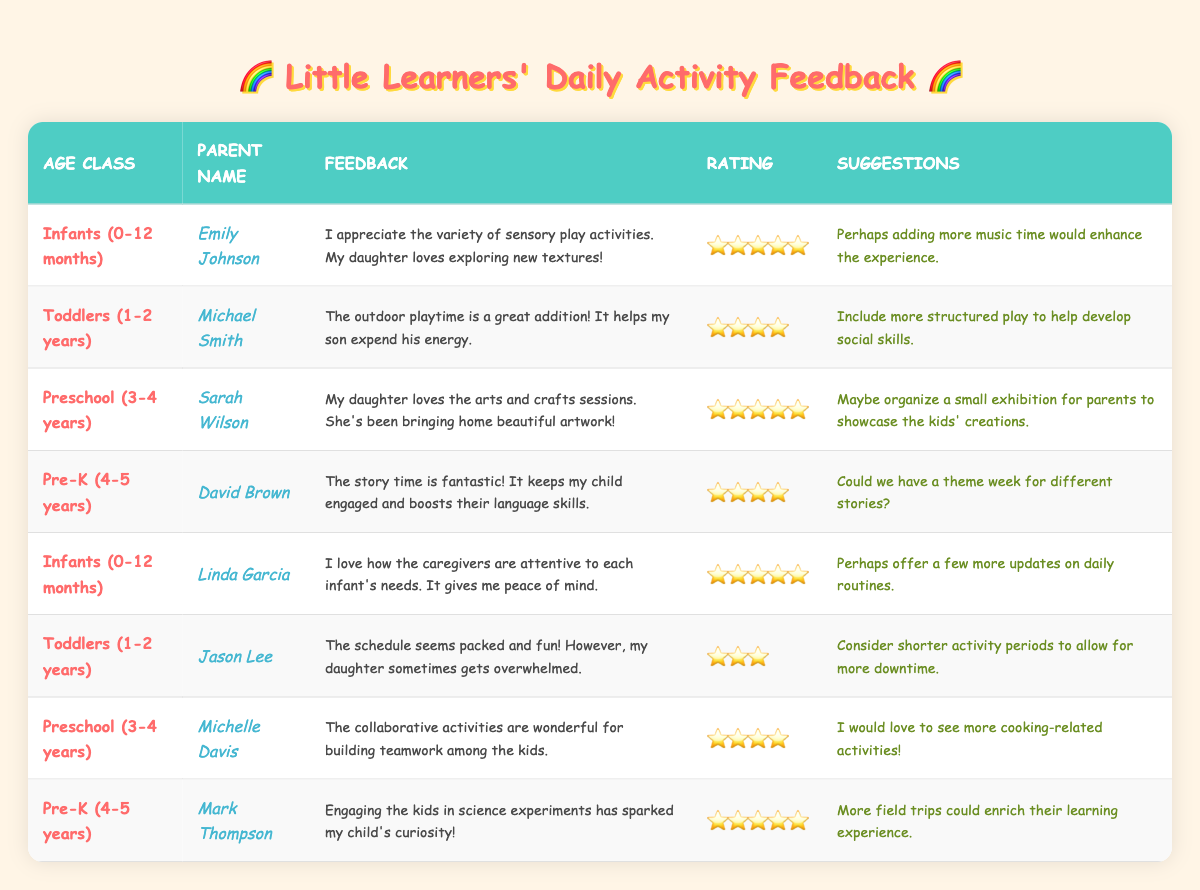What is the highest satisfaction rating given for the Infants age class? The table shows two feedback entries for the Infants age class: Emily Johnson and Linda Garcia both provided a satisfaction rating of 5.
Answer: 5 Which parent provided feedback for the Preschool age class? The table lists two entries for the Preschool age class: Sarah Wilson and Michelle Davis.
Answer: Sarah Wilson and Michelle Davis What suggestions did parents provide for improving the Toddlers age class? The table shows two suggestions for the Toddlers age class: Michael Smith suggested including more structured play, while Jason Lee suggested considering shorter activity periods.
Answer: Include more structured play and shorter activity periods How many parents gave a satisfaction rating of 4? By counting the entries with a satisfaction rating of 4 in the table, there are three parents: Michael Smith, David Brown, and Michelle Davis.
Answer: 3 Which age class had the most feedback entries? Reviewing the table, each age class has two entries except for the Preschool age class which has three entries, indicating it has the most.
Answer: Preschool (3-4 years) What was the average satisfaction rating for the Pre-K age class? The table shows two ratings for the Pre-K age class: 4 from David Brown and 5 from Mark Thompson. The average is (4 + 5) / 2 = 4.5.
Answer: 4.5 Did any parent provide a suggestion to add more music time? Yes, Emily Johnson suggested adding more music time in her feedback for the Infants age class.
Answer: Yes What is the common feedback theme for the Preschool age class? Upon reviewing the comments, both parents who provided feedback for the Preschool age class praised creative activities such as arts and crafts and teamwork, indicating a focus on creativity and collaboration.
Answer: Creativity and collaboration Which age class had the lowest satisfaction rating, and what was it? The lowest satisfaction rating in the table is 3, provided by Jason Lee for the Toddlers age class.
Answer: Toddlers (1-2 years), rating 3 What could improve the experience for Infants according to parent feedback? Suggestions from parents for the Infants age class include adding more music time from Emily Johnson and providing more updates on daily routines from Linda Garcia.
Answer: More music time and more updates on daily routines 